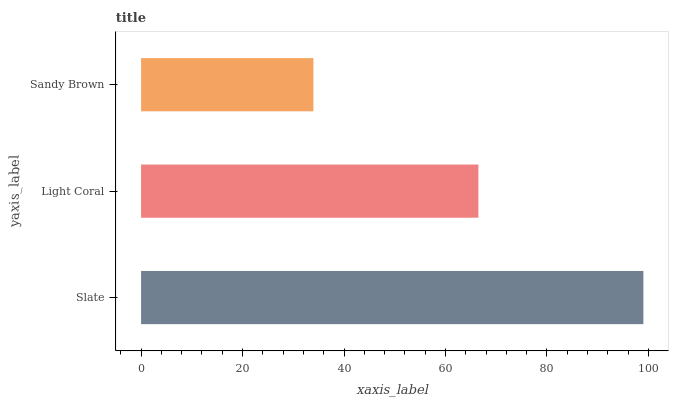Is Sandy Brown the minimum?
Answer yes or no. Yes. Is Slate the maximum?
Answer yes or no. Yes. Is Light Coral the minimum?
Answer yes or no. No. Is Light Coral the maximum?
Answer yes or no. No. Is Slate greater than Light Coral?
Answer yes or no. Yes. Is Light Coral less than Slate?
Answer yes or no. Yes. Is Light Coral greater than Slate?
Answer yes or no. No. Is Slate less than Light Coral?
Answer yes or no. No. Is Light Coral the high median?
Answer yes or no. Yes. Is Light Coral the low median?
Answer yes or no. Yes. Is Sandy Brown the high median?
Answer yes or no. No. Is Sandy Brown the low median?
Answer yes or no. No. 